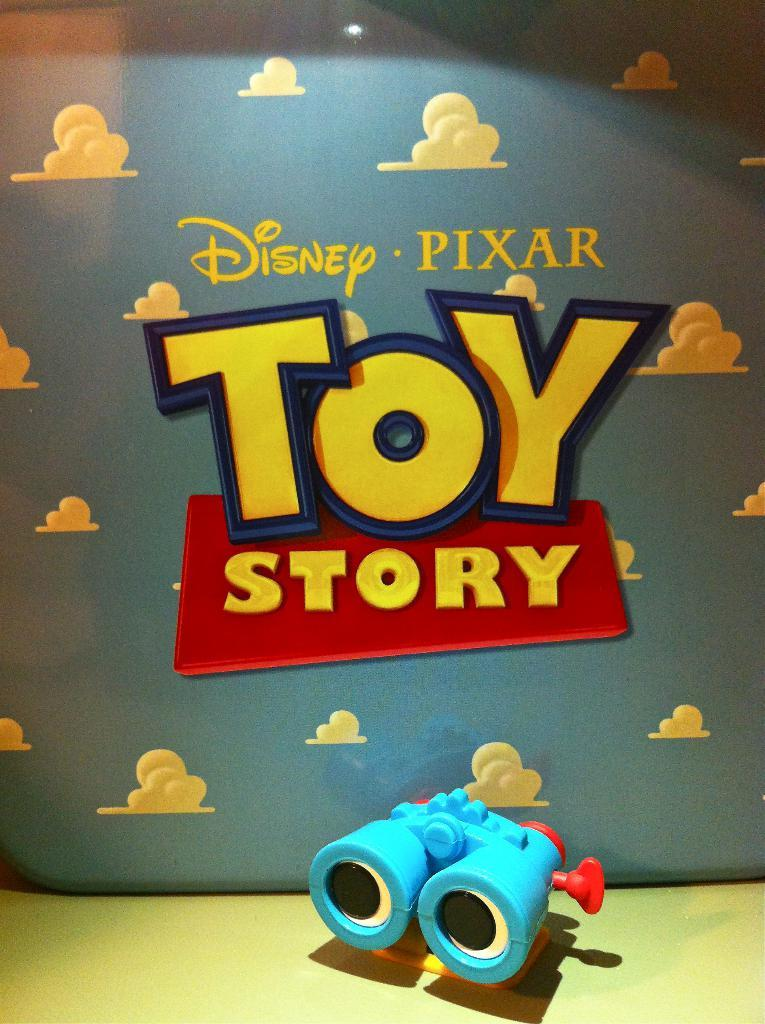<image>
Provide a brief description of the given image. Poster for the movie Toy Story by Disney. 